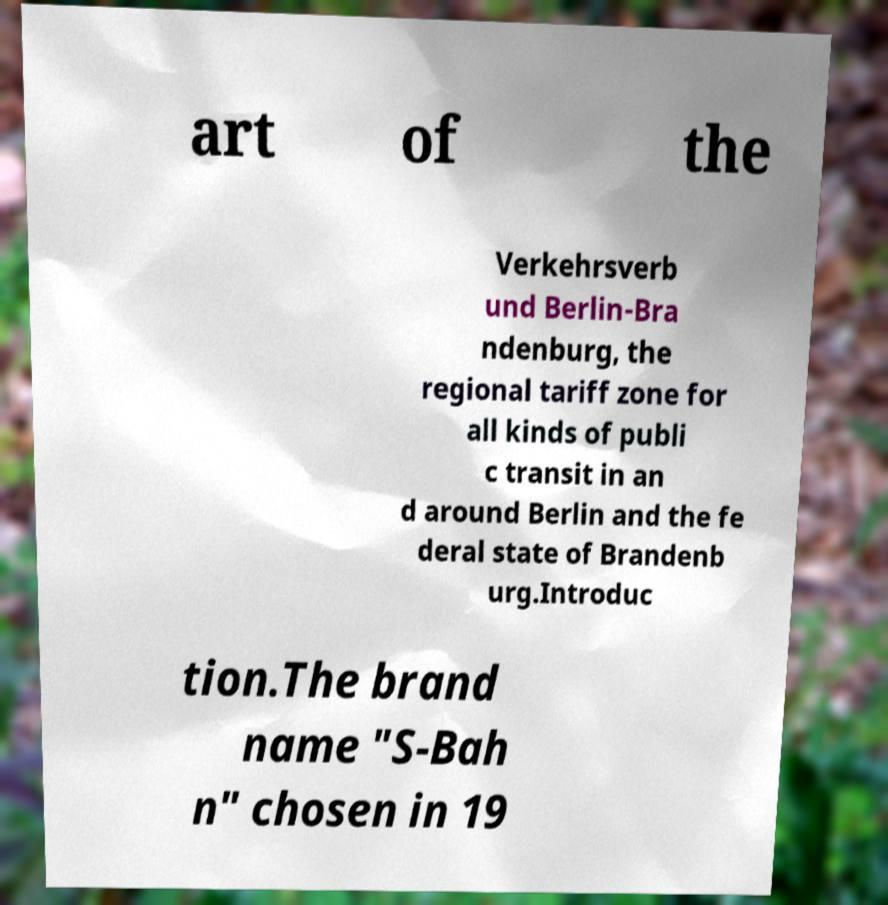For documentation purposes, I need the text within this image transcribed. Could you provide that? art of the Verkehrsverb und Berlin-Bra ndenburg, the regional tariff zone for all kinds of publi c transit in an d around Berlin and the fe deral state of Brandenb urg.Introduc tion.The brand name "S-Bah n" chosen in 19 